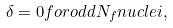<formula> <loc_0><loc_0><loc_500><loc_500>\delta = 0 f o r o d d N _ { f } n u c l e i ,</formula> 